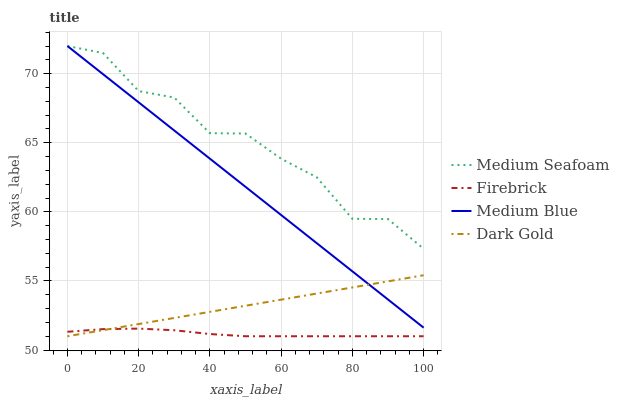Does Medium Blue have the minimum area under the curve?
Answer yes or no. No. Does Medium Blue have the maximum area under the curve?
Answer yes or no. No. Is Medium Seafoam the smoothest?
Answer yes or no. No. Is Medium Blue the roughest?
Answer yes or no. No. Does Medium Blue have the lowest value?
Answer yes or no. No. Does Dark Gold have the highest value?
Answer yes or no. No. Is Dark Gold less than Medium Seafoam?
Answer yes or no. Yes. Is Medium Seafoam greater than Dark Gold?
Answer yes or no. Yes. Does Dark Gold intersect Medium Seafoam?
Answer yes or no. No. 